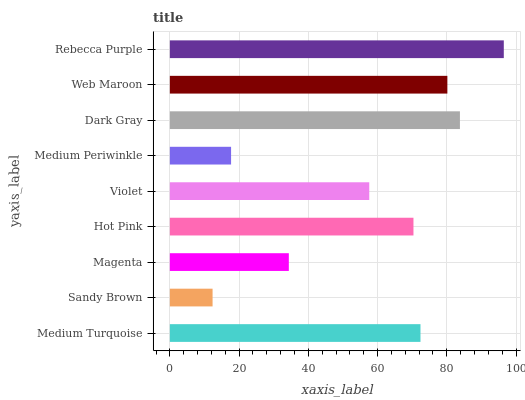Is Sandy Brown the minimum?
Answer yes or no. Yes. Is Rebecca Purple the maximum?
Answer yes or no. Yes. Is Magenta the minimum?
Answer yes or no. No. Is Magenta the maximum?
Answer yes or no. No. Is Magenta greater than Sandy Brown?
Answer yes or no. Yes. Is Sandy Brown less than Magenta?
Answer yes or no. Yes. Is Sandy Brown greater than Magenta?
Answer yes or no. No. Is Magenta less than Sandy Brown?
Answer yes or no. No. Is Hot Pink the high median?
Answer yes or no. Yes. Is Hot Pink the low median?
Answer yes or no. Yes. Is Medium Turquoise the high median?
Answer yes or no. No. Is Magenta the low median?
Answer yes or no. No. 